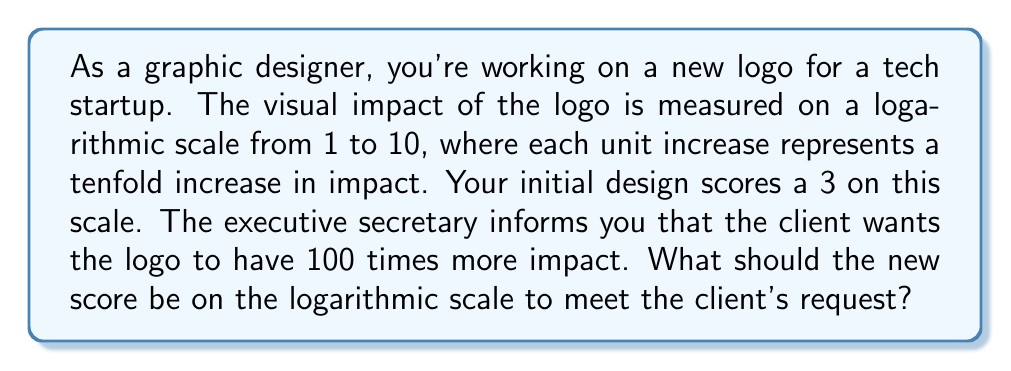Can you solve this math problem? Let's approach this step-by-step:

1) The initial design scores a 3 on the logarithmic scale. This can be represented as:

   $$ \text{Initial Impact} = 10^3 $$

2) The client wants the logo to have 100 times more impact. This means:

   $$ \text{New Impact} = 100 \times 10^3 = 10^5 $$

3) To find the new score on the logarithmic scale, we need to find the logarithm (base 10) of the new impact:

   $$ \text{New Score} = \log_{10}(10^5) $$

4) Using the logarithm property $\log_a(a^x) = x$, we can simplify:

   $$ \text{New Score} = 5 $$

Therefore, to achieve 100 times more impact, the new design should score a 5 on the logarithmic scale.

This makes sense because each unit increase on the scale represents a tenfold increase in impact. From 3 to 4 is a tenfold increase, and from 4 to 5 is another tenfold increase, resulting in a total increase of $10 \times 10 = 100$ times the original impact.
Answer: The new score on the logarithmic scale should be 5. 